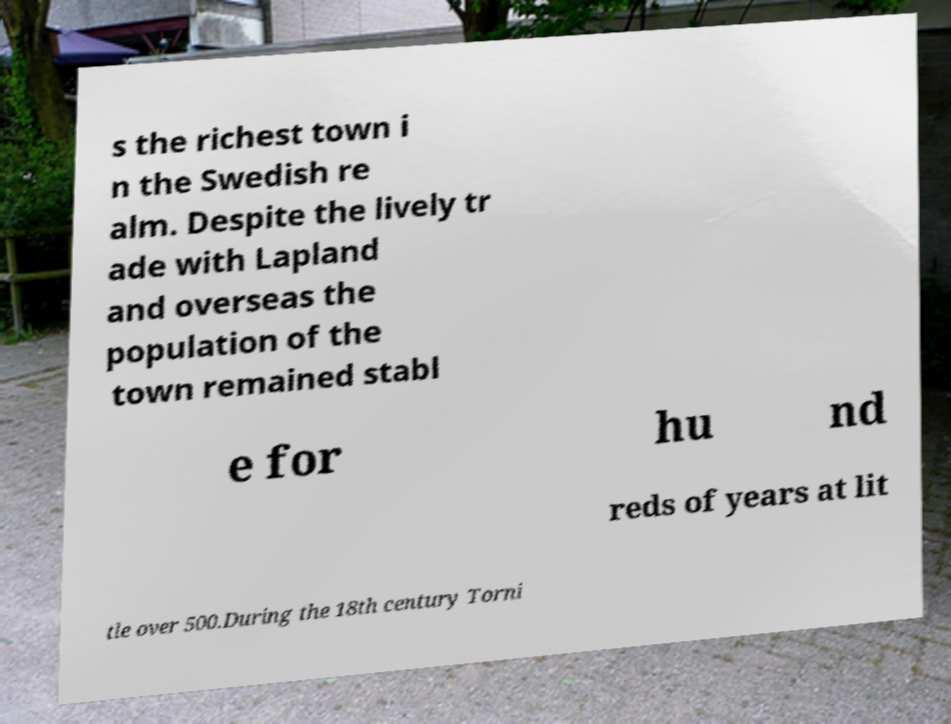Could you extract and type out the text from this image? s the richest town i n the Swedish re alm. Despite the lively tr ade with Lapland and overseas the population of the town remained stabl e for hu nd reds of years at lit tle over 500.During the 18th century Torni 